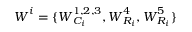<formula> <loc_0><loc_0><loc_500><loc_500>W ^ { i } = \{ W _ { C _ { i } } ^ { 1 , 2 , 3 } , W _ { R _ { i } } ^ { 4 } , W _ { R _ { i } } ^ { 5 } \}</formula> 